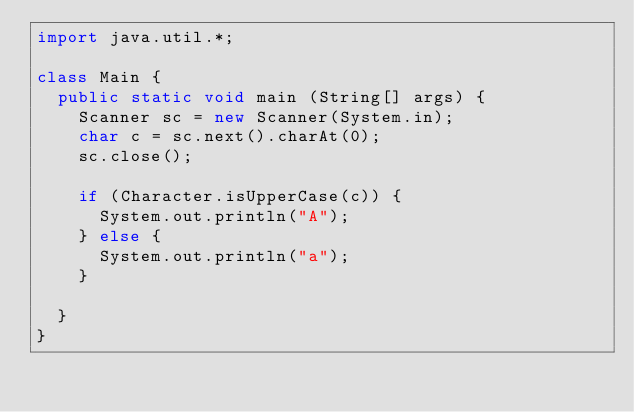Convert code to text. <code><loc_0><loc_0><loc_500><loc_500><_Java_>import java.util.*;

class Main {
  public static void main (String[] args) {
    Scanner sc = new Scanner(System.in);
    char c = sc.next().charAt(0);
    sc.close();
    
    if (Character.isUpperCase(c)) {
    	System.out.println("A");
    } else {
    	System.out.println("a");
    }
    
  }
}
</code> 